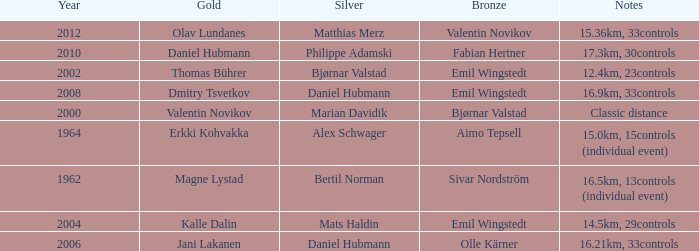WHAT YEAR HAS A SILVER FOR MATTHIAS MERZ? 2012.0. 